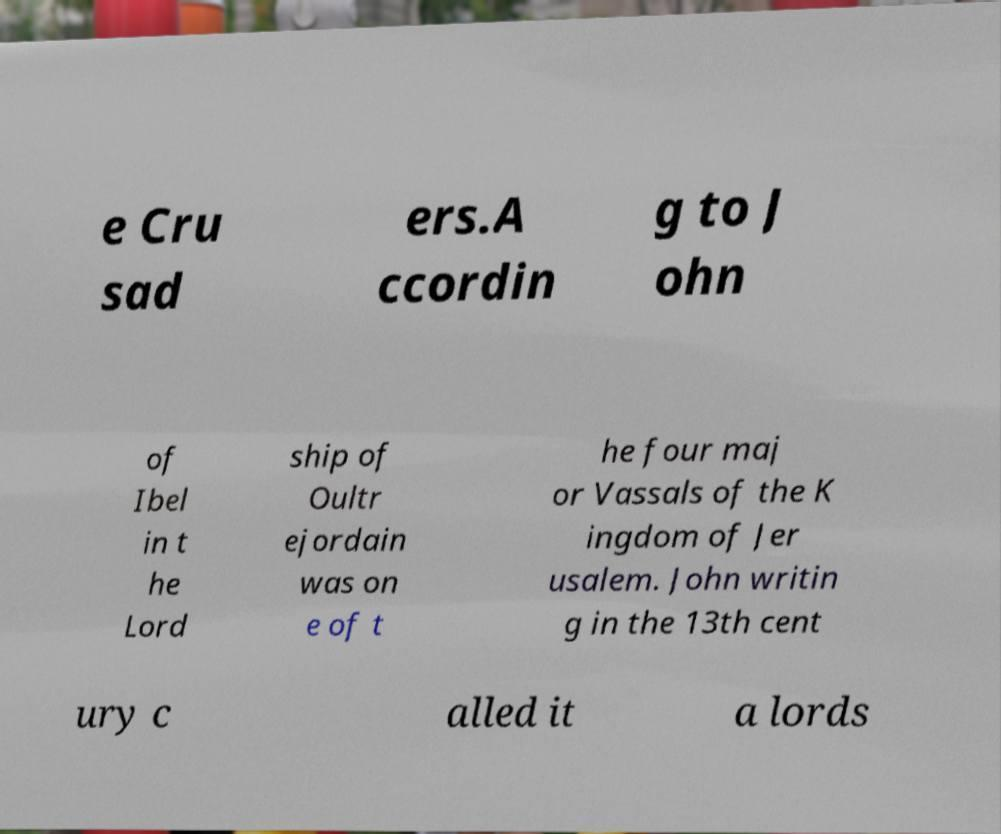Could you extract and type out the text from this image? e Cru sad ers.A ccordin g to J ohn of Ibel in t he Lord ship of Oultr ejordain was on e of t he four maj or Vassals of the K ingdom of Jer usalem. John writin g in the 13th cent ury c alled it a lords 